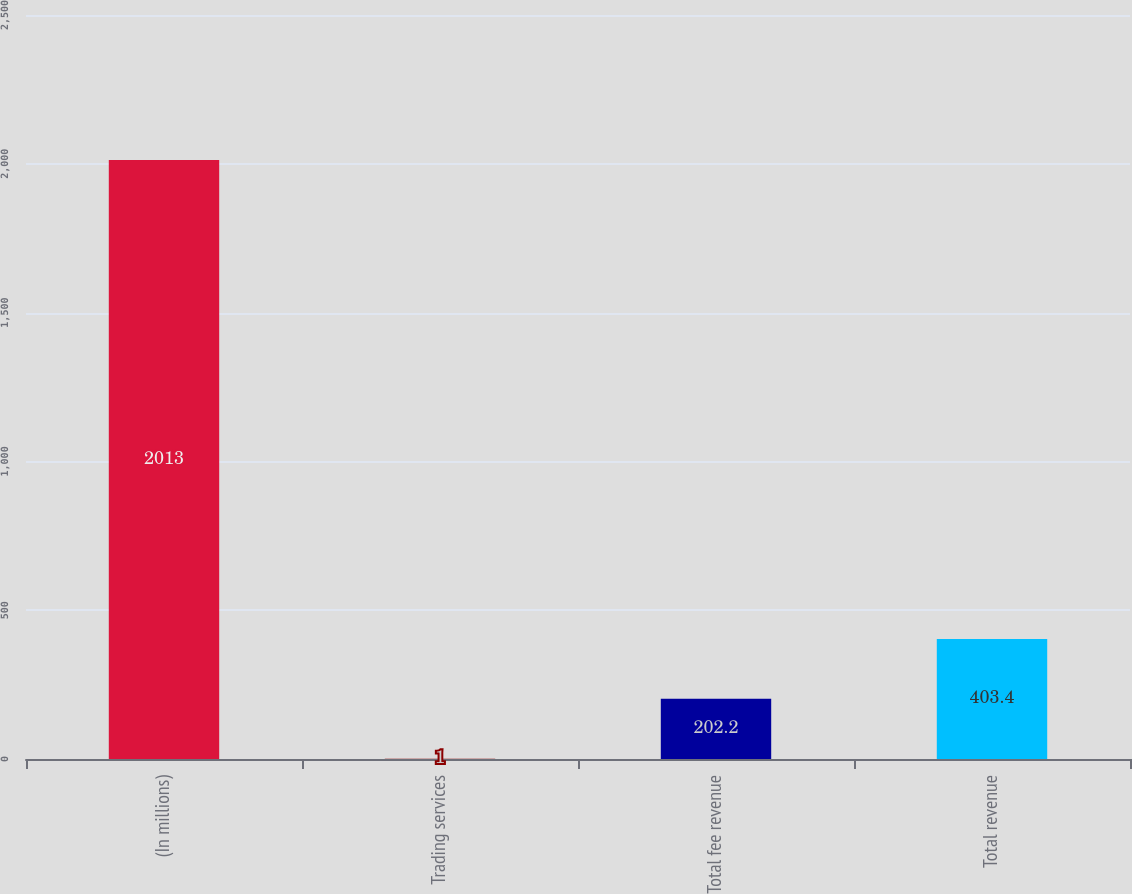<chart> <loc_0><loc_0><loc_500><loc_500><bar_chart><fcel>(In millions)<fcel>Trading services<fcel>Total fee revenue<fcel>Total revenue<nl><fcel>2013<fcel>1<fcel>202.2<fcel>403.4<nl></chart> 